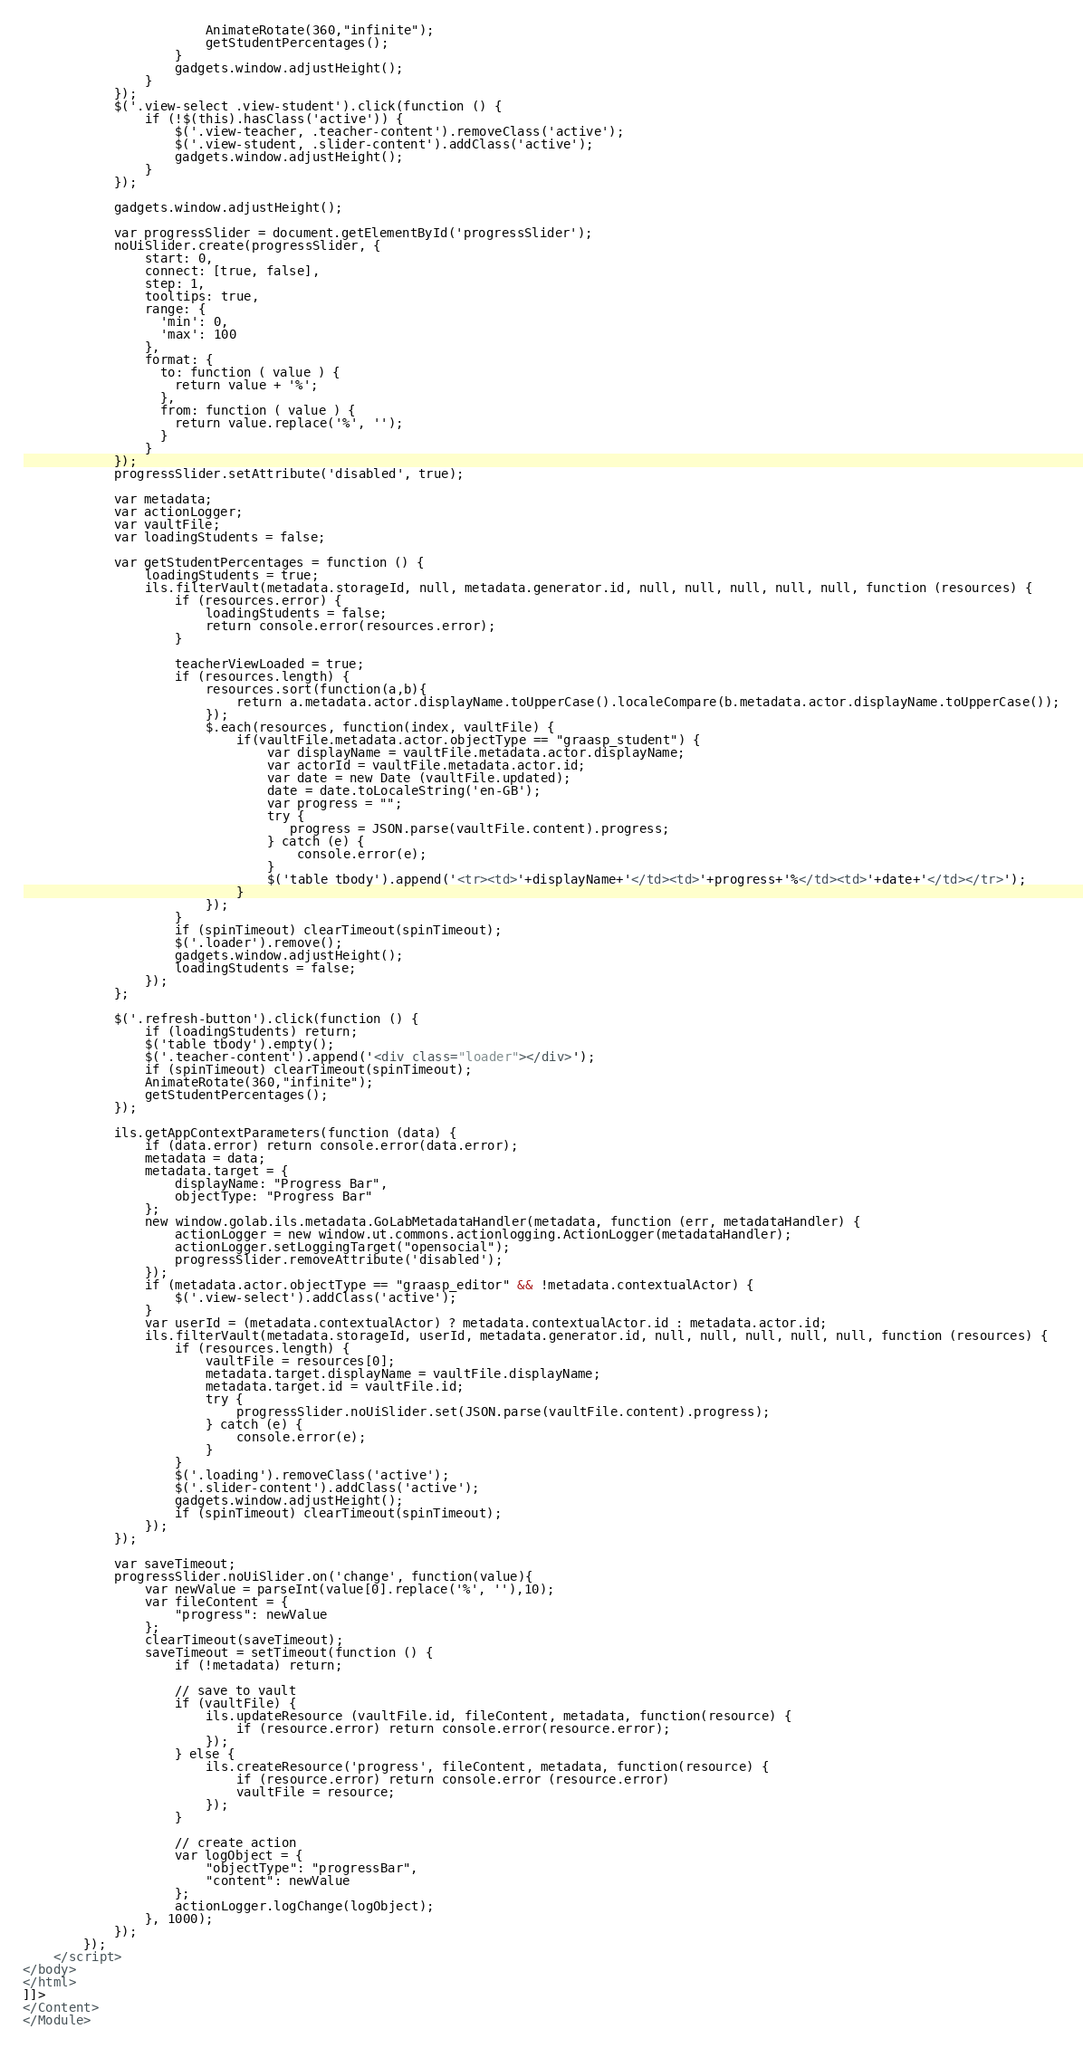<code> <loc_0><loc_0><loc_500><loc_500><_XML_>                        AnimateRotate(360,"infinite");
                        getStudentPercentages();
                    }
                    gadgets.window.adjustHeight();
                }
            });
            $('.view-select .view-student').click(function () {
                if (!$(this).hasClass('active')) {
                    $('.view-teacher, .teacher-content').removeClass('active');
                    $('.view-student, .slider-content').addClass('active');
                    gadgets.window.adjustHeight();
                }
            });
    
            gadgets.window.adjustHeight();

            var progressSlider = document.getElementById('progressSlider');
            noUiSlider.create(progressSlider, {
                start: 0,
                connect: [true, false],
                step: 1,
                tooltips: true,
                range: {
                  'min': 0,
                  'max': 100
                },
                format: {
                  to: function ( value ) {
                    return value + '%';
                  },
                  from: function ( value ) {
                    return value.replace('%', '');
                  }
                }
            });
            progressSlider.setAttribute('disabled', true);

            var metadata;
            var actionLogger;
            var vaultFile;
            var loadingStudents = false;

            var getStudentPercentages = function () {
                loadingStudents = true;
                ils.filterVault(metadata.storageId, null, metadata.generator.id, null, null, null, null, null, function (resources) {
                    if (resources.error) {
                        loadingStudents = false;
                        return console.error(resources.error);
                    }

                    teacherViewLoaded = true;
                    if (resources.length) {
                        resources.sort(function(a,b){
                            return a.metadata.actor.displayName.toUpperCase().localeCompare(b.metadata.actor.displayName.toUpperCase());
                        });
                        $.each(resources, function(index, vaultFile) {
                            if(vaultFile.metadata.actor.objectType == "graasp_student") {
                                var displayName = vaultFile.metadata.actor.displayName;
                                var actorId = vaultFile.metadata.actor.id;
                                var date = new Date (vaultFile.updated);
                                date = date.toLocaleString('en-GB');
                                var progress = "";
                                try {
                                   progress = JSON.parse(vaultFile.content).progress;
                                } catch (e) {
                                    console.error(e);
                                }
                                $('table tbody').append('<tr><td>'+displayName+'</td><td>'+progress+'%</td><td>'+date+'</td></tr>');
                            }
                        });
                    }
                    if (spinTimeout) clearTimeout(spinTimeout);
                    $('.loader').remove();
                    gadgets.window.adjustHeight();
                    loadingStudents = false;
                });
            };

            $('.refresh-button').click(function () {
                if (loadingStudents) return;
                $('table tbody').empty();
                $('.teacher-content').append('<div class="loader"></div>');
                if (spinTimeout) clearTimeout(spinTimeout);
                AnimateRotate(360,"infinite");
                getStudentPercentages();
            });

            ils.getAppContextParameters(function (data) {
                if (data.error) return console.error(data.error);
                metadata = data;
                metadata.target = {
                    displayName: "Progress Bar",
                    objectType: "Progress Bar"
                };
                new window.golab.ils.metadata.GoLabMetadataHandler(metadata, function (err, metadataHandler) {
                    actionLogger = new window.ut.commons.actionlogging.ActionLogger(metadataHandler);
                    actionLogger.setLoggingTarget("opensocial");
                    progressSlider.removeAttribute('disabled');
                });
                if (metadata.actor.objectType == "graasp_editor" && !metadata.contextualActor) {
                    $('.view-select').addClass('active');
                }
                var userId = (metadata.contextualActor) ? metadata.contextualActor.id : metadata.actor.id;
                ils.filterVault(metadata.storageId, userId, metadata.generator.id, null, null, null, null, null, function (resources) {
                    if (resources.length) {
                        vaultFile = resources[0];
                        metadata.target.displayName = vaultFile.displayName;
                        metadata.target.id = vaultFile.id;
                        try {
                            progressSlider.noUiSlider.set(JSON.parse(vaultFile.content).progress);
                        } catch (e) {
                            console.error(e);
                        }
                    }
                    $('.loading').removeClass('active');
                    $('.slider-content').addClass('active');
                    gadgets.window.adjustHeight();
                    if (spinTimeout) clearTimeout(spinTimeout);
                });
            });

            var saveTimeout;
            progressSlider.noUiSlider.on('change', function(value){
                var newValue = parseInt(value[0].replace('%', ''),10);
                var fileContent = {
                    "progress": newValue
                };
                clearTimeout(saveTimeout);
                saveTimeout = setTimeout(function () {
                    if (!metadata) return;

                    // save to vault
                    if (vaultFile) {
                        ils.updateResource (vaultFile.id, fileContent, metadata, function(resource) {
                            if (resource.error) return console.error(resource.error);
                        });
                    } else {
                        ils.createResource('progress', fileContent, metadata, function(resource) {
                            if (resource.error) return console.error (resource.error)
                            vaultFile = resource;
                        });
                    }

                    // create action
                    var logObject = {
                        "objectType": "progressBar",
                        "content": newValue
                    };
                    actionLogger.logChange(logObject);
                }, 1000);
            });
        });
    </script>
</body>
</html>
]]>
</Content>
</Module>
</code> 